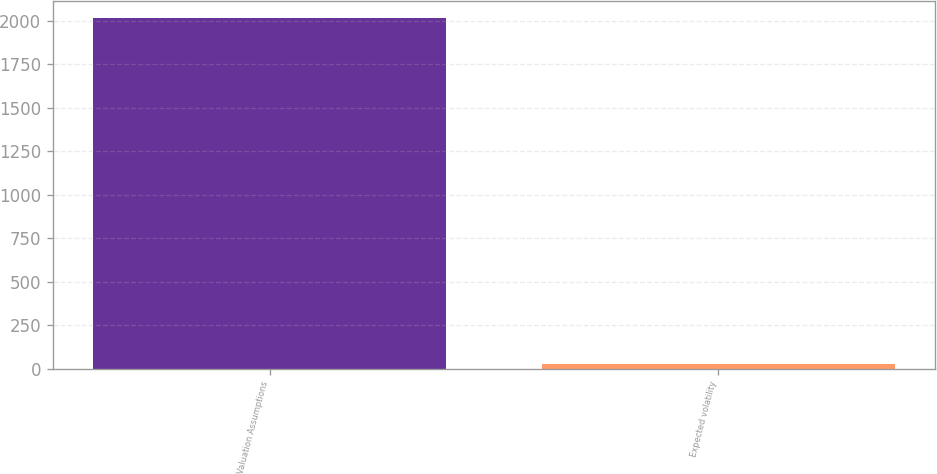<chart> <loc_0><loc_0><loc_500><loc_500><bar_chart><fcel>Valuation Assumptions<fcel>Expected volatility<nl><fcel>2016<fcel>24.37<nl></chart> 